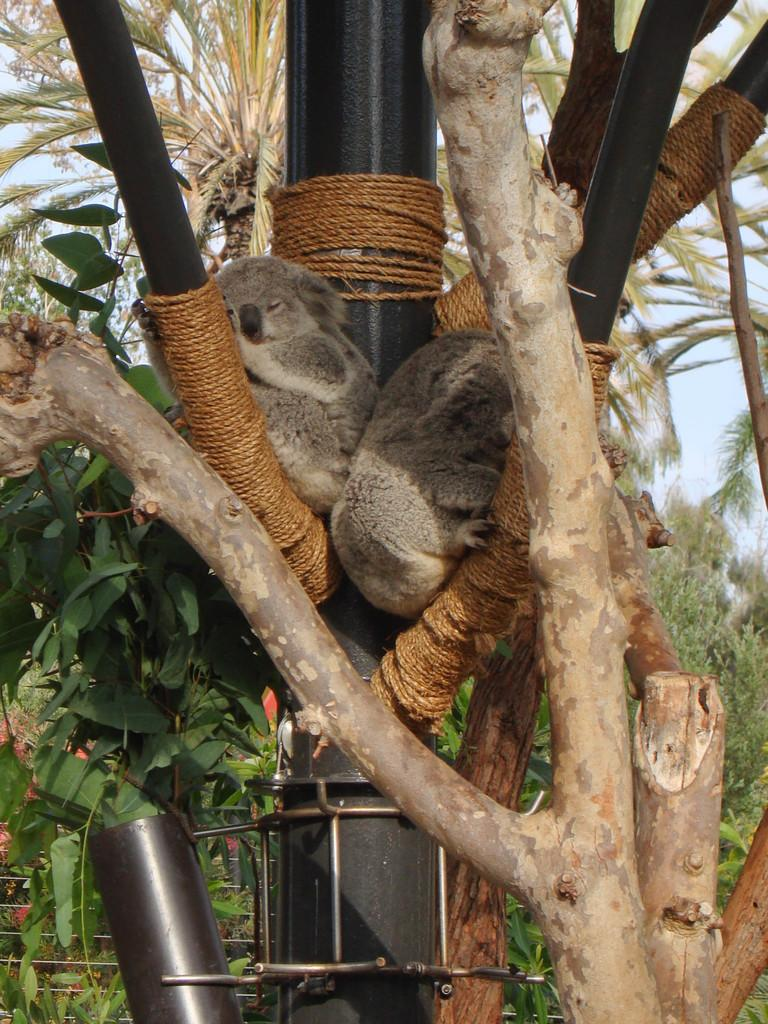What type of vegetation can be seen in the image? There are trees in the image. What is located between the trees? There is a black metal pole between the trees. What animals are present in the image? Two koalas are sleeping on the black metal pole. How is the black metal pole secured? The black metal pole is tied around with a rope. What type of approval does the dad give in the image? There is no dad present in the image, and therefore no approval can be given. What kind of error is visible in the image? There is no error visible in the image; it features trees, a black metal pole, and two koalas sleeping on the pole. 